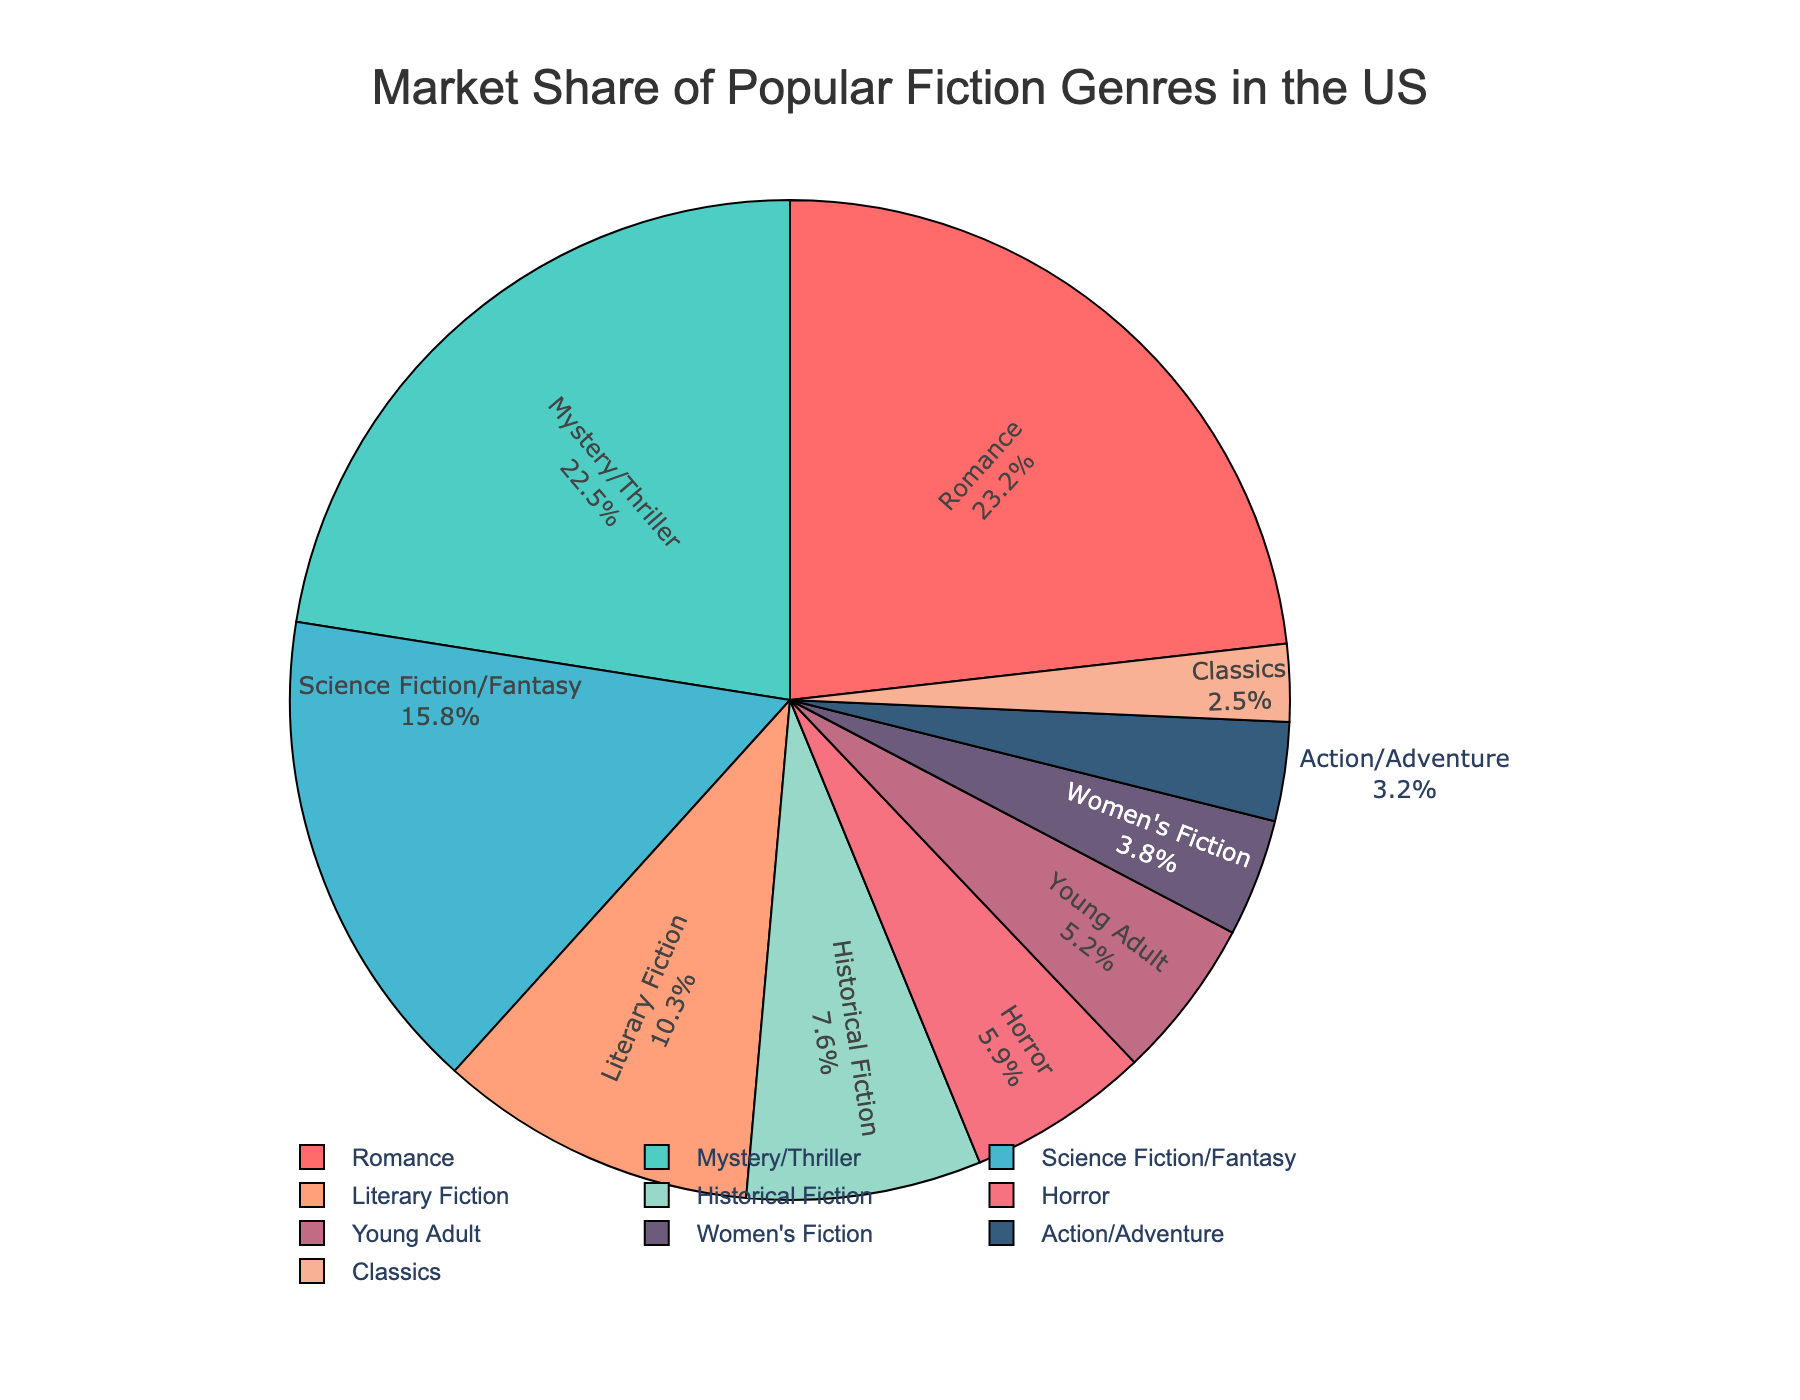What's the most popular fiction genre in the US by market share? The market share for each genre is shown on the pie chart. The Romance genre has the largest section of the pie chart, indicating it has the highest market share.
Answer: Romance Which genre has the smallest market share? The Young Adult and Women's Fiction genres have smaller shares, but Classics has the smallest section of the pie chart.
Answer: Classics What is the combined market share of Romance and Mystery/Thriller genres? The market share for Romance is 23.2%, and for Mystery/Thriller, it is 22.5%. Adding these together: 23.2 + 22.5 = 45.7%.
Answer: 45.7% Which genre has a larger market share: Horror or Action/Adventure? Compare the sizes of the slices for Horror and Action/Adventure. Horror has a larger section than Action/Adventure on the pie chart.
Answer: Horror What is the total market share of genres with over 20% market share? The genres with over 20% market share are Romance (23.2%) and Mystery/Thriller (22.5%). Adding these together: 23.2 + 22.5 = 45.7%.
Answer: 45.7% How much more market share does Science Fiction/Fantasy have compared to Historical Fiction? The market share for Science Fiction/Fantasy is 15.8%, and for Historical Fiction, it is 7.6%. Subtracting these: 15.8 - 7.6 = 8.2%.
Answer: 8.2% What is the average market share of Action/Adventure, Classics, and Young Adult genres? Add the market shares of Action/Adventure (3.2%), Classics (2.5%), and Young Adult (5.2%), then divide by 3: (3.2 + 2.5 + 5.2) / 3 = 10.9 / 3 ≈ 3.63%.
Answer: 3.63% Which genres have a market share between 5% and 10%? The genres with a market share in this range are Horror (5.9%), Young Adult (5.2%), and Historical Fiction (7.6%).
Answer: Horror, Young Adult, Historical Fiction How does the market share of Women's Fiction compare to Literary Fiction? Compare the percentage values. Women's Fiction has a market share of 3.8%, while Literary Fiction has 10.3%. Literary Fiction has a larger market share.
Answer: Literary Fiction 